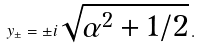<formula> <loc_0><loc_0><loc_500><loc_500>y _ { \pm } = \pm i \sqrt { \alpha ^ { 2 } + 1 / 2 } \, .</formula> 